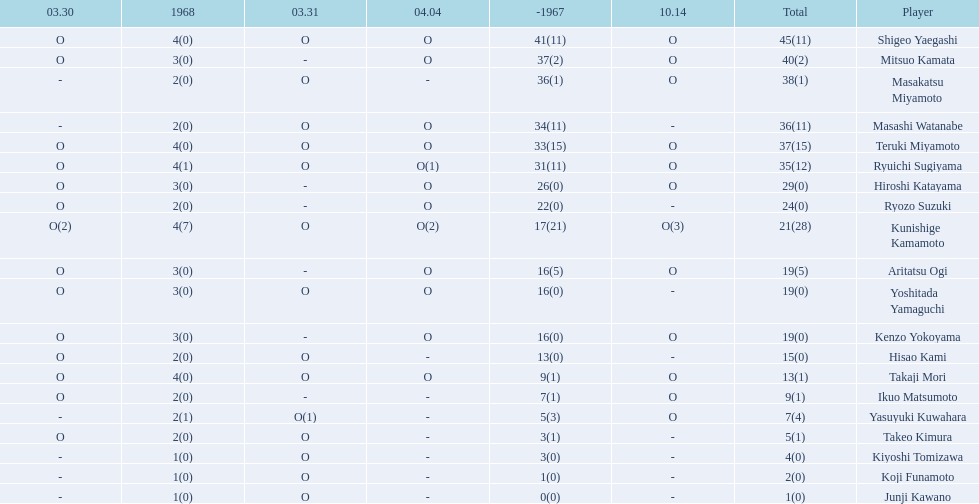Who were the players in the 1968 japanese football? Shigeo Yaegashi, Mitsuo Kamata, Masakatsu Miyamoto, Masashi Watanabe, Teruki Miyamoto, Ryuichi Sugiyama, Hiroshi Katayama, Ryozo Suzuki, Kunishige Kamamoto, Aritatsu Ogi, Yoshitada Yamaguchi, Kenzo Yokoyama, Hisao Kami, Takaji Mori, Ikuo Matsumoto, Yasuyuki Kuwahara, Takeo Kimura, Kiyoshi Tomizawa, Koji Funamoto, Junji Kawano. How many points total did takaji mori have? 13(1). How many points total did junju kawano? 1(0). Who had more points? Takaji Mori. 